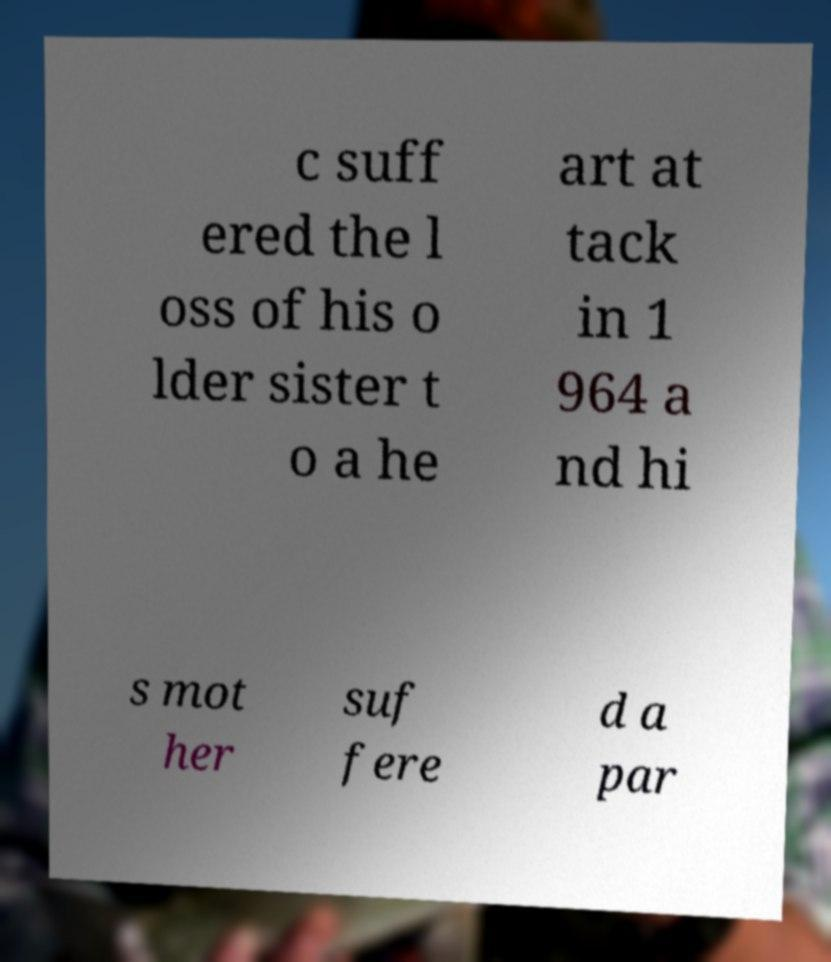There's text embedded in this image that I need extracted. Can you transcribe it verbatim? c suff ered the l oss of his o lder sister t o a he art at tack in 1 964 a nd hi s mot her suf fere d a par 